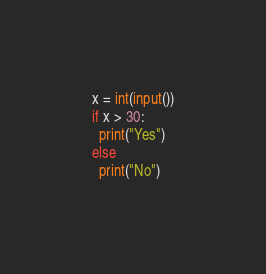Convert code to text. <code><loc_0><loc_0><loc_500><loc_500><_Python_>x = int(input())
if x > 30:
  print("Yes")
else
  print("No")</code> 